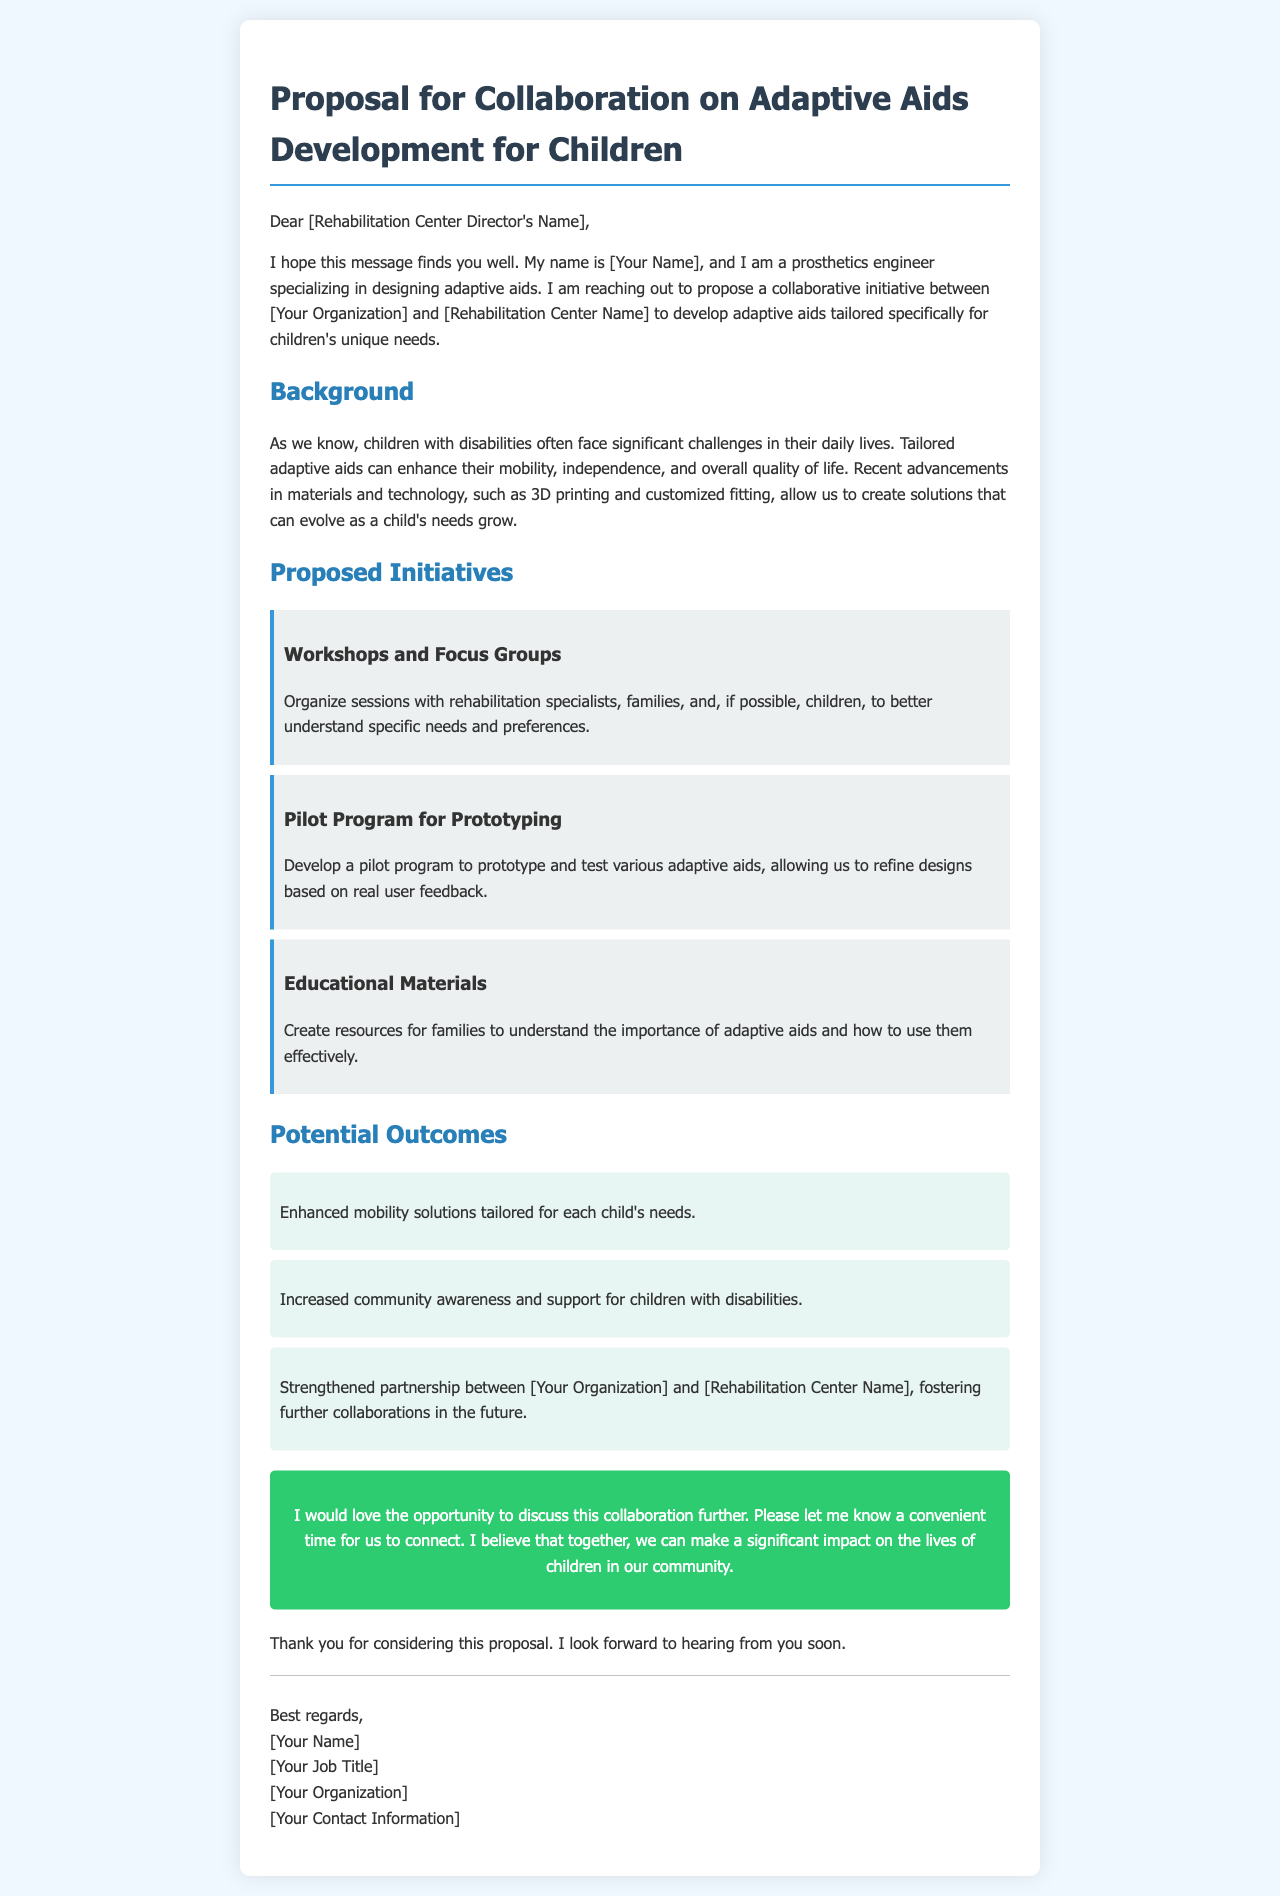what is the title of the proposal? The title of the proposal is stated clearly at the top of the document: "Proposal for Collaboration on Adaptive Aids Development for Children."
Answer: Proposal for Collaboration on Adaptive Aids Development for Children who is the author of the email? The author of the email introduces themselves as "[Your Name]" in the greeting and signature sections.
Answer: [Your Name] what is the focus of the proposed collaboration? The email conveys a proposal to collaborate on developing adaptive aids specifically for children's unique needs.
Answer: developing adaptive aids tailored for children's needs what is one of the proposed initiatives mentioned in the email? The email lists specific initiatives aimed at understanding children's needs, one of which is "Workshops and Focus Groups."
Answer: Workshops and Focus Groups how many potential outcomes are outlined in the document? The document outlines a total of three potential outcomes of the collaboration.
Answer: three what is included in the call-to-action section? The call-to-action section encourages a further discussion regarding the collaboration and requests a convenient time to connect.
Answer: opportunity to discuss this collaboration further how does the author sign off the email? The author signs off the email with "Best regards," followed by their name and title in the signature section.
Answer: Best regards what technology is mentioned as a part of the adaptive aids development? The document mentions "3D printing" as a recent advancement in technology relevant to the development of adaptive aids.
Answer: 3D printing 